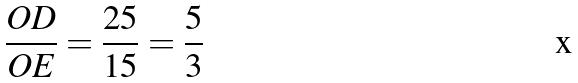Convert formula to latex. <formula><loc_0><loc_0><loc_500><loc_500>\frac { O D } { O E } = \frac { 2 5 } { 1 5 } = \frac { 5 } { 3 }</formula> 